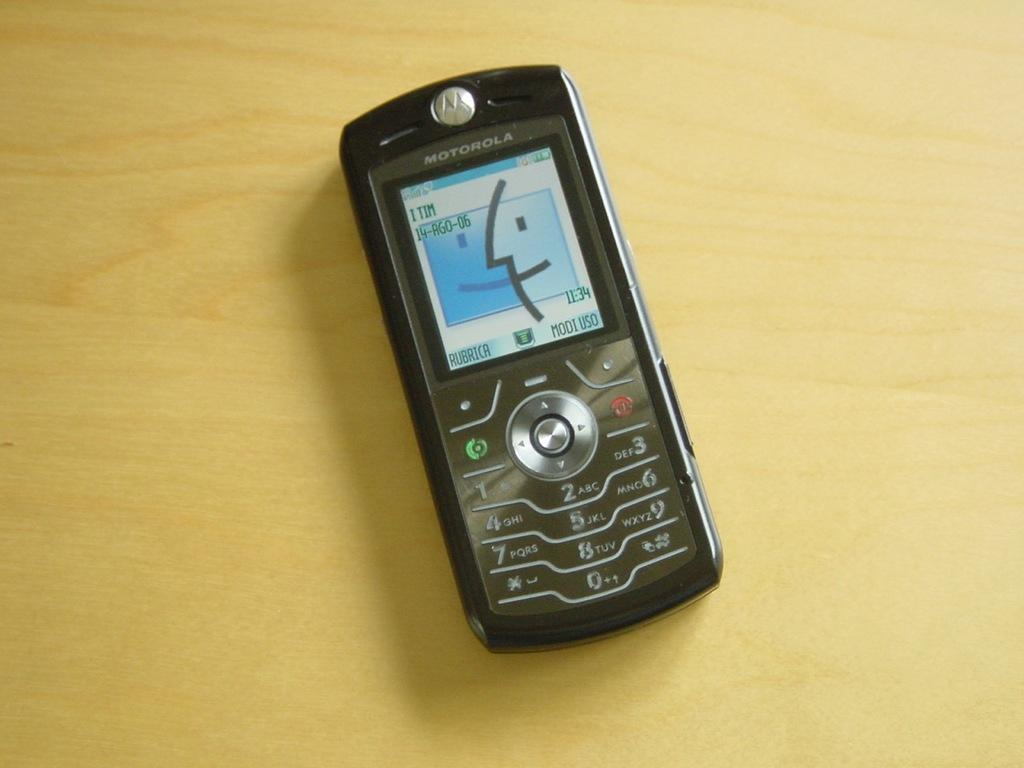<image>
Present a compact description of the photo's key features. The time is 11:34 according to the Motorola cell phone displayed on the table. 